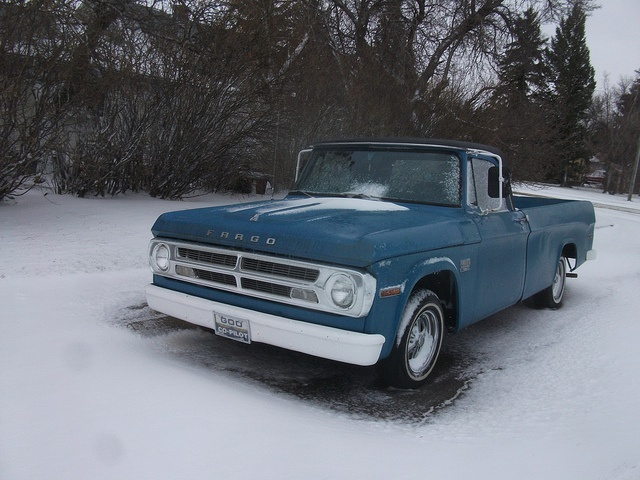Describe the objects in this image and their specific colors. I can see a truck in gray, blue, black, and darkgray tones in this image. 